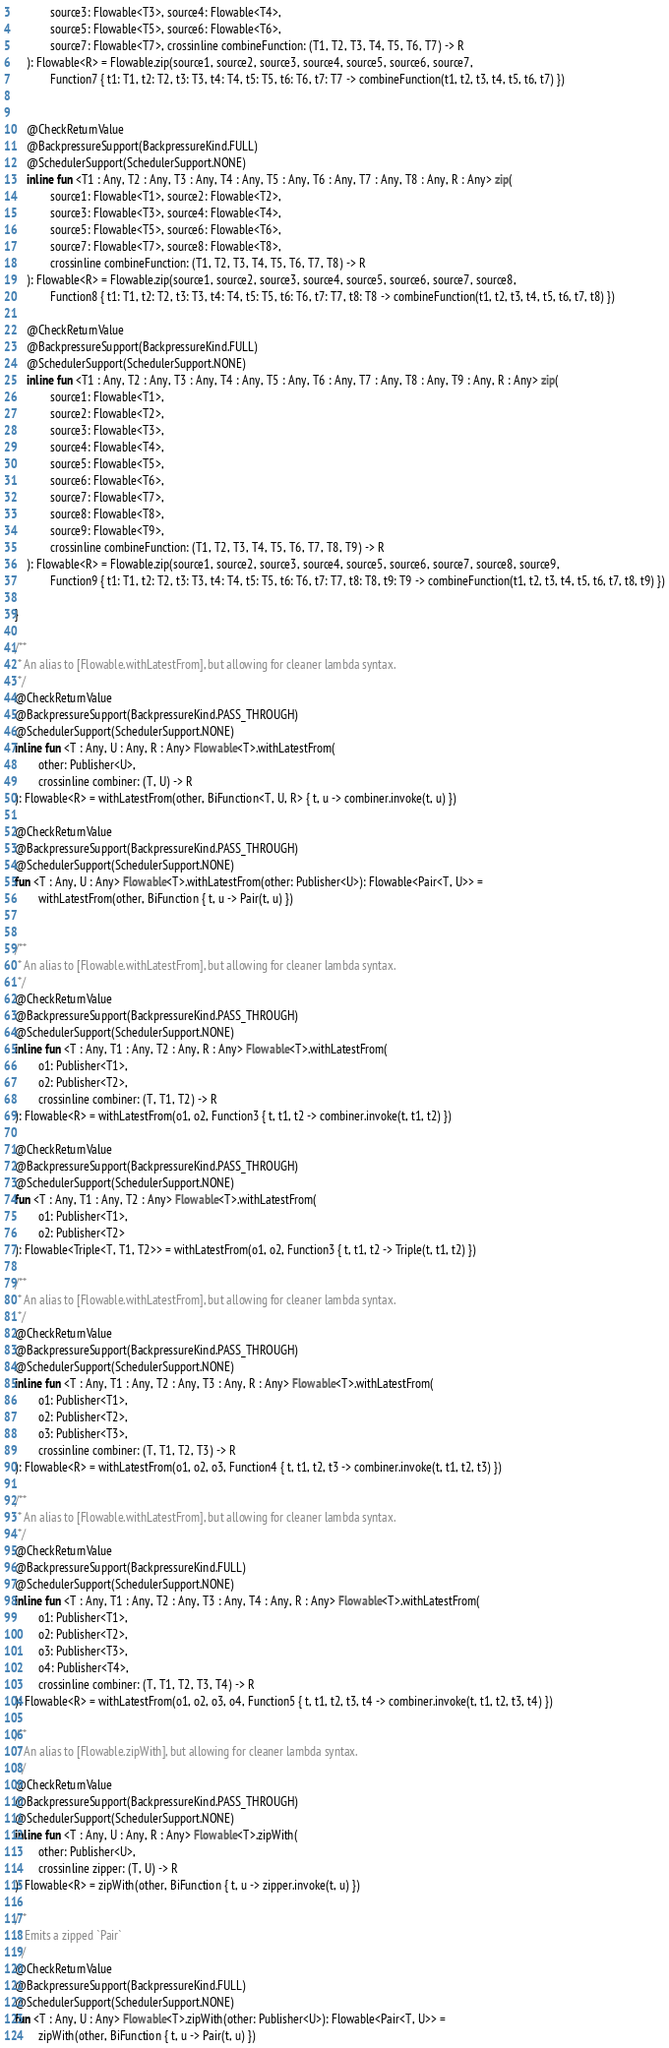Convert code to text. <code><loc_0><loc_0><loc_500><loc_500><_Kotlin_>            source3: Flowable<T3>, source4: Flowable<T4>,
            source5: Flowable<T5>, source6: Flowable<T6>,
            source7: Flowable<T7>, crossinline combineFunction: (T1, T2, T3, T4, T5, T6, T7) -> R
    ): Flowable<R> = Flowable.zip(source1, source2, source3, source4, source5, source6, source7,
            Function7 { t1: T1, t2: T2, t3: T3, t4: T4, t5: T5, t6: T6, t7: T7 -> combineFunction(t1, t2, t3, t4, t5, t6, t7) })


    @CheckReturnValue
    @BackpressureSupport(BackpressureKind.FULL)
    @SchedulerSupport(SchedulerSupport.NONE)
    inline fun <T1 : Any, T2 : Any, T3 : Any, T4 : Any, T5 : Any, T6 : Any, T7 : Any, T8 : Any, R : Any> zip(
            source1: Flowable<T1>, source2: Flowable<T2>,
            source3: Flowable<T3>, source4: Flowable<T4>,
            source5: Flowable<T5>, source6: Flowable<T6>,
            source7: Flowable<T7>, source8: Flowable<T8>,
            crossinline combineFunction: (T1, T2, T3, T4, T5, T6, T7, T8) -> R
    ): Flowable<R> = Flowable.zip(source1, source2, source3, source4, source5, source6, source7, source8,
            Function8 { t1: T1, t2: T2, t3: T3, t4: T4, t5: T5, t6: T6, t7: T7, t8: T8 -> combineFunction(t1, t2, t3, t4, t5, t6, t7, t8) })

    @CheckReturnValue
    @BackpressureSupport(BackpressureKind.FULL)
    @SchedulerSupport(SchedulerSupport.NONE)
    inline fun <T1 : Any, T2 : Any, T3 : Any, T4 : Any, T5 : Any, T6 : Any, T7 : Any, T8 : Any, T9 : Any, R : Any> zip(
            source1: Flowable<T1>,
            source2: Flowable<T2>,
            source3: Flowable<T3>,
            source4: Flowable<T4>,
            source5: Flowable<T5>,
            source6: Flowable<T6>,
            source7: Flowable<T7>,
            source8: Flowable<T8>,
            source9: Flowable<T9>,
            crossinline combineFunction: (T1, T2, T3, T4, T5, T6, T7, T8, T9) -> R
    ): Flowable<R> = Flowable.zip(source1, source2, source3, source4, source5, source6, source7, source8, source9,
            Function9 { t1: T1, t2: T2, t3: T3, t4: T4, t5: T5, t6: T6, t7: T7, t8: T8, t9: T9 -> combineFunction(t1, t2, t3, t4, t5, t6, t7, t8, t9) })

}

/**
 * An alias to [Flowable.withLatestFrom], but allowing for cleaner lambda syntax.
 */
@CheckReturnValue
@BackpressureSupport(BackpressureKind.PASS_THROUGH)
@SchedulerSupport(SchedulerSupport.NONE)
inline fun <T : Any, U : Any, R : Any> Flowable<T>.withLatestFrom(
        other: Publisher<U>,
        crossinline combiner: (T, U) -> R
): Flowable<R> = withLatestFrom(other, BiFunction<T, U, R> { t, u -> combiner.invoke(t, u) })

@CheckReturnValue
@BackpressureSupport(BackpressureKind.PASS_THROUGH)
@SchedulerSupport(SchedulerSupport.NONE)
fun <T : Any, U : Any> Flowable<T>.withLatestFrom(other: Publisher<U>): Flowable<Pair<T, U>> =
        withLatestFrom(other, BiFunction { t, u -> Pair(t, u) })


/**
 * An alias to [Flowable.withLatestFrom], but allowing for cleaner lambda syntax.
 */
@CheckReturnValue
@BackpressureSupport(BackpressureKind.PASS_THROUGH)
@SchedulerSupport(SchedulerSupport.NONE)
inline fun <T : Any, T1 : Any, T2 : Any, R : Any> Flowable<T>.withLatestFrom(
        o1: Publisher<T1>,
        o2: Publisher<T2>,
        crossinline combiner: (T, T1, T2) -> R
): Flowable<R> = withLatestFrom(o1, o2, Function3 { t, t1, t2 -> combiner.invoke(t, t1, t2) })

@CheckReturnValue
@BackpressureSupport(BackpressureKind.PASS_THROUGH)
@SchedulerSupport(SchedulerSupport.NONE)
fun <T : Any, T1 : Any, T2 : Any> Flowable<T>.withLatestFrom(
        o1: Publisher<T1>,
        o2: Publisher<T2>
): Flowable<Triple<T, T1, T2>> = withLatestFrom(o1, o2, Function3 { t, t1, t2 -> Triple(t, t1, t2) })

/**
 * An alias to [Flowable.withLatestFrom], but allowing for cleaner lambda syntax.
 */
@CheckReturnValue
@BackpressureSupport(BackpressureKind.PASS_THROUGH)
@SchedulerSupport(SchedulerSupport.NONE)
inline fun <T : Any, T1 : Any, T2 : Any, T3 : Any, R : Any> Flowable<T>.withLatestFrom(
        o1: Publisher<T1>,
        o2: Publisher<T2>,
        o3: Publisher<T3>,
        crossinline combiner: (T, T1, T2, T3) -> R
): Flowable<R> = withLatestFrom(o1, o2, o3, Function4 { t, t1, t2, t3 -> combiner.invoke(t, t1, t2, t3) })

/**
 * An alias to [Flowable.withLatestFrom], but allowing for cleaner lambda syntax.
 */
@CheckReturnValue
@BackpressureSupport(BackpressureKind.FULL)
@SchedulerSupport(SchedulerSupport.NONE)
inline fun <T : Any, T1 : Any, T2 : Any, T3 : Any, T4 : Any, R : Any> Flowable<T>.withLatestFrom(
        o1: Publisher<T1>,
        o2: Publisher<T2>,
        o3: Publisher<T3>,
        o4: Publisher<T4>,
        crossinline combiner: (T, T1, T2, T3, T4) -> R
): Flowable<R> = withLatestFrom(o1, o2, o3, o4, Function5 { t, t1, t2, t3, t4 -> combiner.invoke(t, t1, t2, t3, t4) })

/**
 * An alias to [Flowable.zipWith], but allowing for cleaner lambda syntax.
 */
@CheckReturnValue
@BackpressureSupport(BackpressureKind.PASS_THROUGH)
@SchedulerSupport(SchedulerSupport.NONE)
inline fun <T : Any, U : Any, R : Any> Flowable<T>.zipWith(
        other: Publisher<U>,
        crossinline zipper: (T, U) -> R
): Flowable<R> = zipWith(other, BiFunction { t, u -> zipper.invoke(t, u) })

/**
 * Emits a zipped `Pair`
 */
@CheckReturnValue
@BackpressureSupport(BackpressureKind.FULL)
@SchedulerSupport(SchedulerSupport.NONE)
fun <T : Any, U : Any> Flowable<T>.zipWith(other: Publisher<U>): Flowable<Pair<T, U>> =
        zipWith(other, BiFunction { t, u -> Pair(t, u) })
</code> 